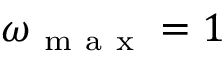<formula> <loc_0><loc_0><loc_500><loc_500>\omega _ { m a x } = 1</formula> 